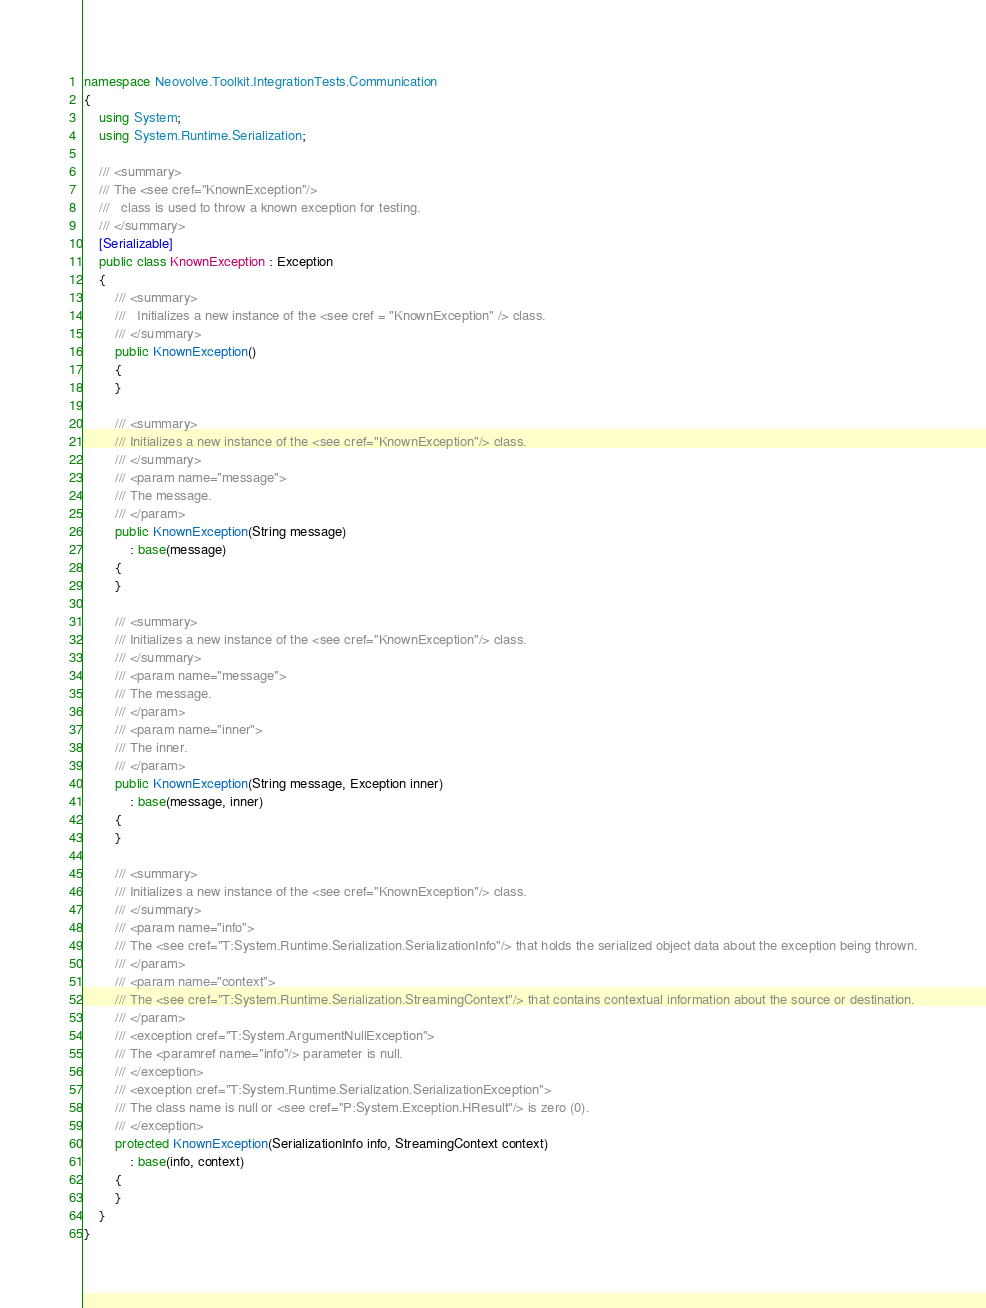<code> <loc_0><loc_0><loc_500><loc_500><_C#_>namespace Neovolve.Toolkit.IntegrationTests.Communication
{
    using System;
    using System.Runtime.Serialization;

    /// <summary>
    /// The <see cref="KnownException"/>
    ///   class is used to throw a known exception for testing.
    /// </summary>
    [Serializable]
    public class KnownException : Exception
    {
        /// <summary>
        ///   Initializes a new instance of the <see cref = "KnownException" /> class.
        /// </summary>
        public KnownException()
        {
        }

        /// <summary>
        /// Initializes a new instance of the <see cref="KnownException"/> class.
        /// </summary>
        /// <param name="message">
        /// The message.
        /// </param>
        public KnownException(String message)
            : base(message)
        {
        }

        /// <summary>
        /// Initializes a new instance of the <see cref="KnownException"/> class.
        /// </summary>
        /// <param name="message">
        /// The message.
        /// </param>
        /// <param name="inner">
        /// The inner.
        /// </param>
        public KnownException(String message, Exception inner)
            : base(message, inner)
        {
        }

        /// <summary>
        /// Initializes a new instance of the <see cref="KnownException"/> class.
        /// </summary>
        /// <param name="info">
        /// The <see cref="T:System.Runtime.Serialization.SerializationInfo"/> that holds the serialized object data about the exception being thrown.
        /// </param>
        /// <param name="context">
        /// The <see cref="T:System.Runtime.Serialization.StreamingContext"/> that contains contextual information about the source or destination.
        /// </param>
        /// <exception cref="T:System.ArgumentNullException">
        /// The <paramref name="info"/> parameter is null. 
        /// </exception>
        /// <exception cref="T:System.Runtime.Serialization.SerializationException">
        /// The class name is null or <see cref="P:System.Exception.HResult"/> is zero (0). 
        /// </exception>
        protected KnownException(SerializationInfo info, StreamingContext context)
            : base(info, context)
        {
        }
    }
}</code> 